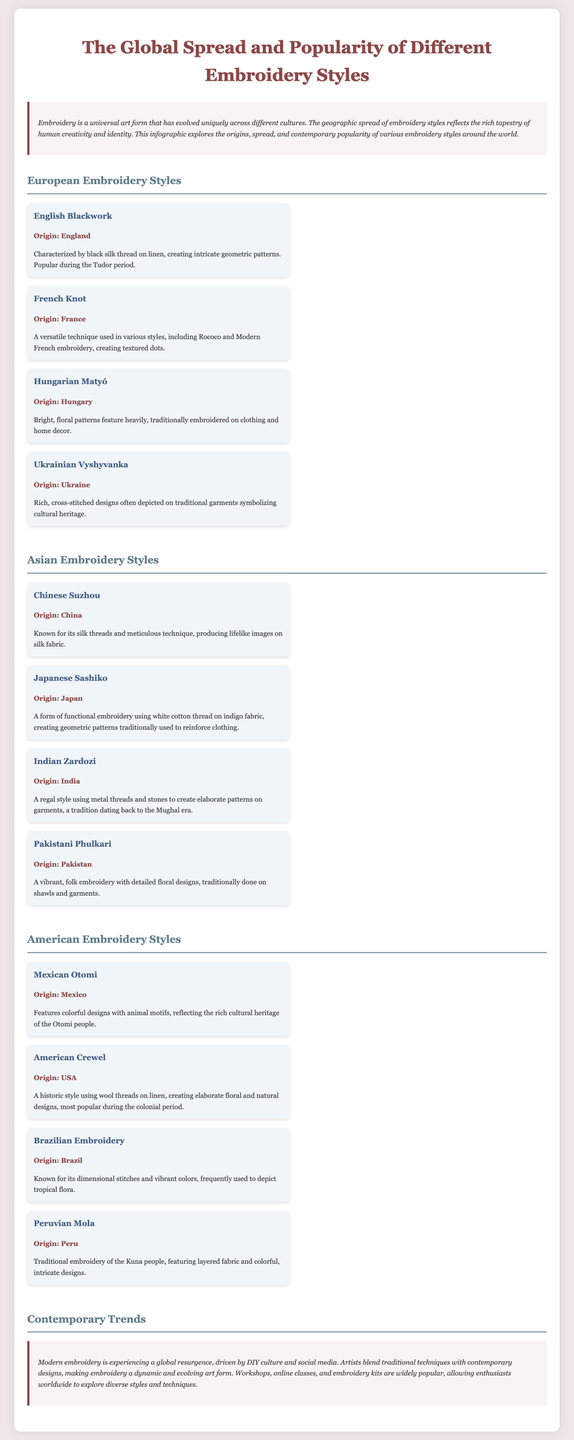What is the title of the infographic? The title of the infographic is found at the top of the document.
Answer: The Global Spread and Popularity of Different Embroidery Styles What style of embroidery is characterized by floral patterns in Hungary? The document lists various embroidery styles and their characteristics, highlighting Hungarian Matyó.
Answer: Hungarian Matyó Which Asian embroidery style uses white cotton thread on indigo fabric? The document describes several Asian embroidery styles, specifically noting Japanese Sashiko for its unique characteristics.
Answer: Japanese Sashiko What is the origin of the French Knot embroidery style? The origin of each embroidery style is mentioned under the style's name in the document.
Answer: France Which American embroidery style features colorful designs with animal motifs? The American section details various styles, identifying Mexican Otomi as a style with specific motifs.
Answer: Mexican Otomi How does modern embroidery's popularity relate to DIY culture? The document mentions that modern embroidery is experiencing a resurgence due to social media and DIY culture initiatives.
Answer: Global resurgence What are workshops and online classes described as in contemporary trends? The document discusses the accessibility of embroidery learning, mentioning workshops and online classes as popular means of learning.
Answer: Widely popular How many embroidery styles are listed under the European section? The document provides a structured layout, allowing the reader to count the styles featured in the European section.
Answer: Four What type of fabric is commonly associated with American Crewel embroidery? The document explicitly states the type of fabric associated with different embroidery styles.
Answer: Linen 